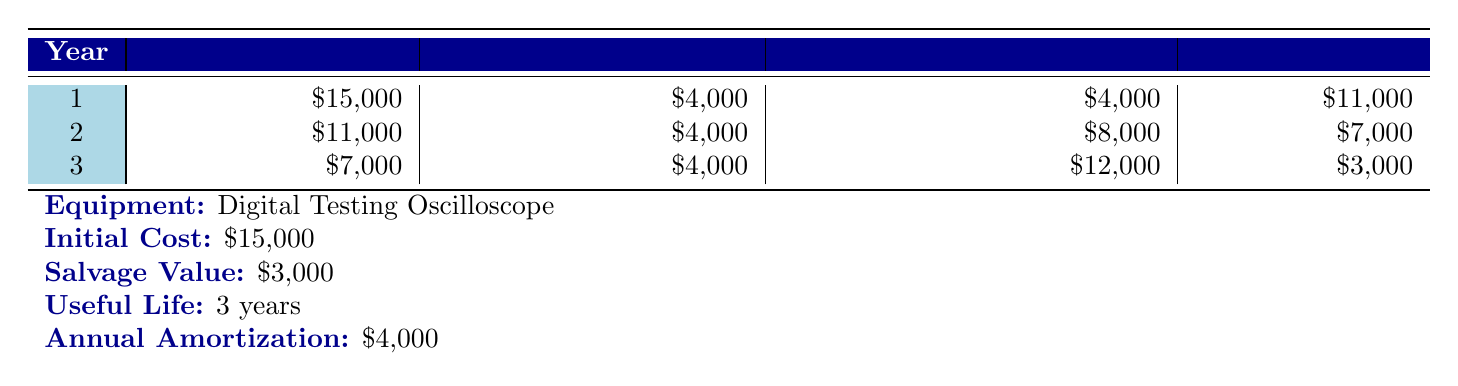What is the initial cost of the Digital Testing Oscilloscope? The initial cost is directly listed in the table under the equipment details. It states $15,000.
Answer: 15000 What is the amortization expense for year 2? The amortization expense for each year is provided in the table. For year 2, it is $4,000.
Answer: 4000 What is the ending balance at the end of year 1? The ending balance for year 1 is given in the table as $11,000.
Answer: 11000 Is the accumulated amortization at the end of year 3 greater than the initial cost? At the end of year 3, the accumulated amortization is $12,000, which is not greater than the initial cost of $15,000. Hence, the statement is false.
Answer: No What is the total amortization expense over the 3-year period? To find the total amortization expense, sum the annual expenses from the table: $4,000 + $4,000 + $4,000 = $12,000.
Answer: 12000 What is the salvage value of the equipment? The salvage value is specified in the table as $3,000.
Answer: 3000 In which year is the ending balance lowest? By checking the ending balances for each year provided in the table, year 3 shows the lowest ending balance of $3,000.
Answer: Year 3 What is the difference between the ending balance in year 1 and year 2? The ending balance in year 1 is $11,000 and in year 2 is $7,000. The difference is calculated as $11,000 - $7,000 = $4,000.
Answer: 4000 Does the third year have a higher amortization expense than the first year? The amortization expense for both the first and third years is $4,000, making this statement false.
Answer: No 